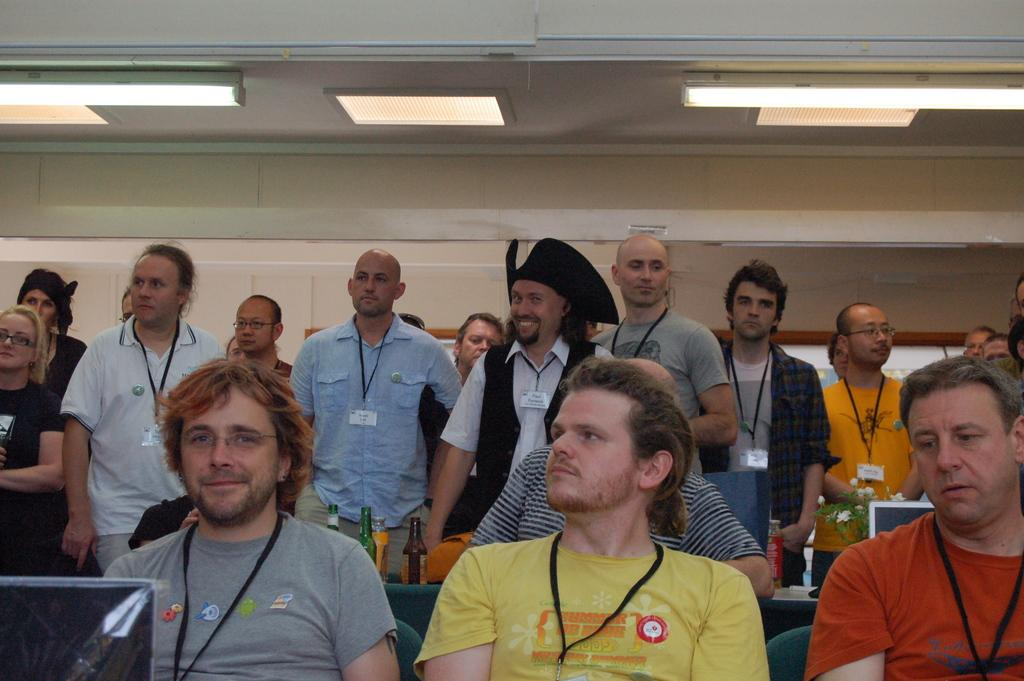What are the people in the room doing? Some people are standing, and others are sitting in the room. What objects can be seen in the room? There are bottles and a plant in the room. What is on the table in the room? There is a system on the table. What can be seen on the ceiling in the room? There are lights on the ceiling. How many beggars are present in the room? There is no mention of any beggars in the room; the image only shows people standing and sitting. What type of apparatus is being used by the representative in the room? There is no representative present in the room, and no apparatus is mentioned in the image. 